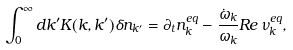<formula> <loc_0><loc_0><loc_500><loc_500>\int _ { 0 } ^ { \infty } d k ^ { \prime } K ( k , k ^ { \prime } ) \delta n _ { k ^ { \prime } } = \partial _ { t } n ^ { e q } _ { k } - \frac { \dot { \omega } _ { k } } { \omega _ { k } } { R e } \, \nu _ { k } ^ { e q } ,</formula> 